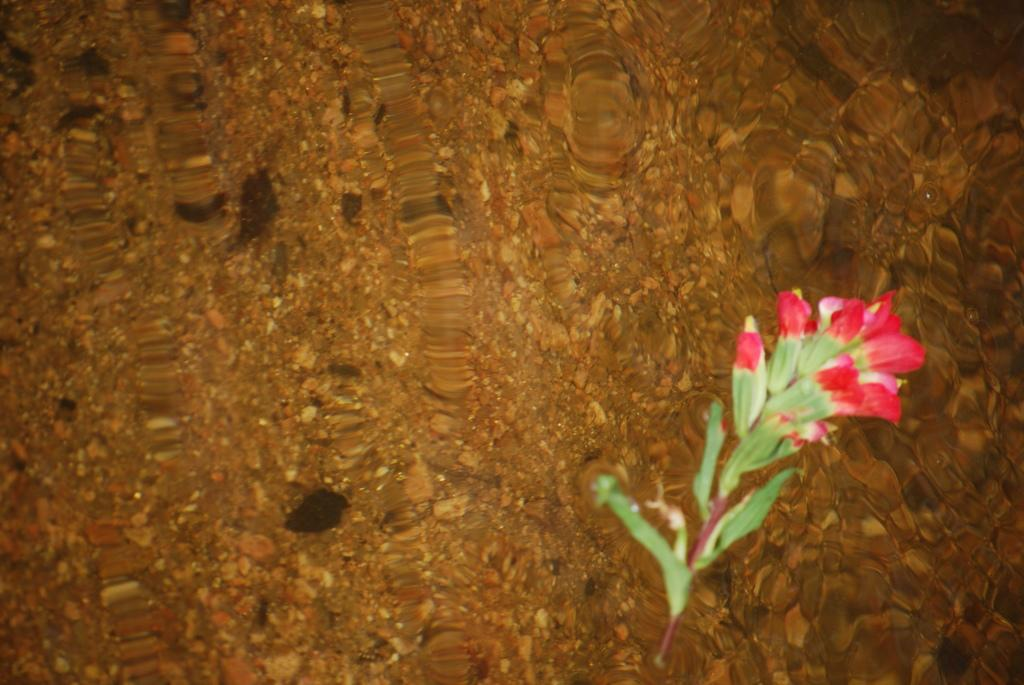What type of plant can be seen in the image? There is a plant with flowers in the image. What can be seen in the background of the image? There are stones and objects in the water in the background of the image. What is the governor's opinion on the plant in the image? There is no reference to a governor or their opinion in the image, so it cannot be determined. 